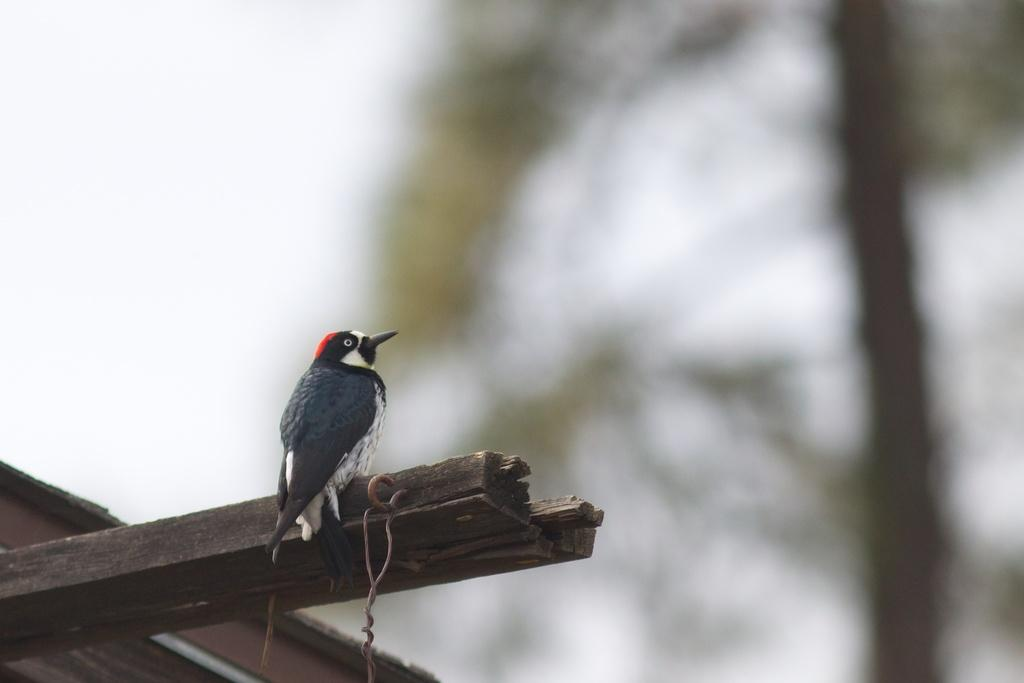What type of animal is present in the image? There is a bird in the image. Where is the bird located in the image? The bird is on a wooden stick. What news is the bird reporting in the image? There is no indication in the image that the bird is reporting any news. 